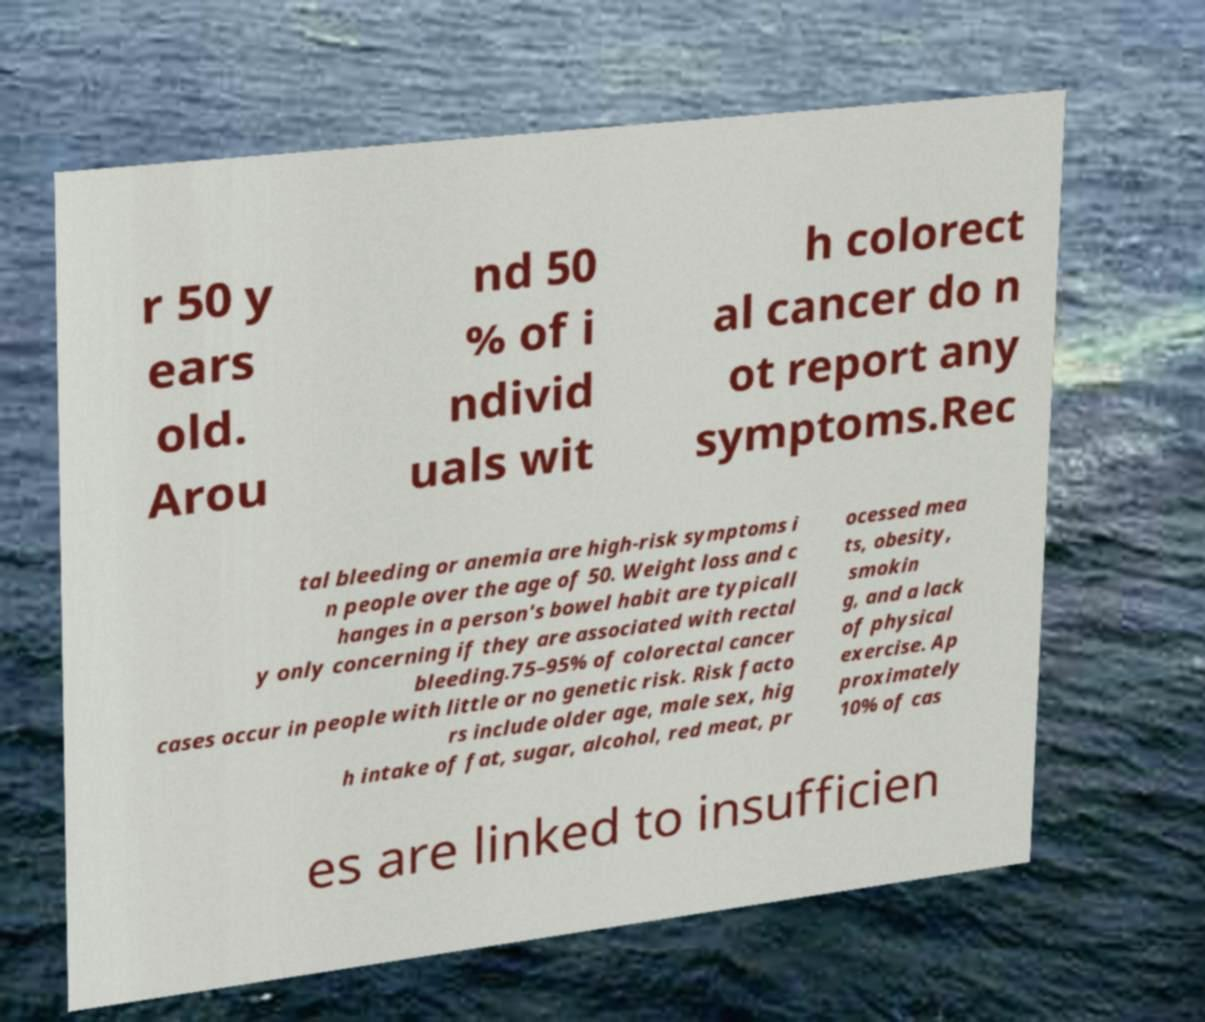Could you extract and type out the text from this image? r 50 y ears old. Arou nd 50 % of i ndivid uals wit h colorect al cancer do n ot report any symptoms.Rec tal bleeding or anemia are high-risk symptoms i n people over the age of 50. Weight loss and c hanges in a person's bowel habit are typicall y only concerning if they are associated with rectal bleeding.75–95% of colorectal cancer cases occur in people with little or no genetic risk. Risk facto rs include older age, male sex, hig h intake of fat, sugar, alcohol, red meat, pr ocessed mea ts, obesity, smokin g, and a lack of physical exercise. Ap proximately 10% of cas es are linked to insufficien 